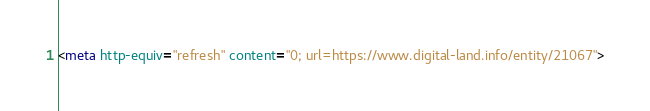<code> <loc_0><loc_0><loc_500><loc_500><_HTML_><meta http-equiv="refresh" content="0; url=https://www.digital-land.info/entity/21067"></code> 